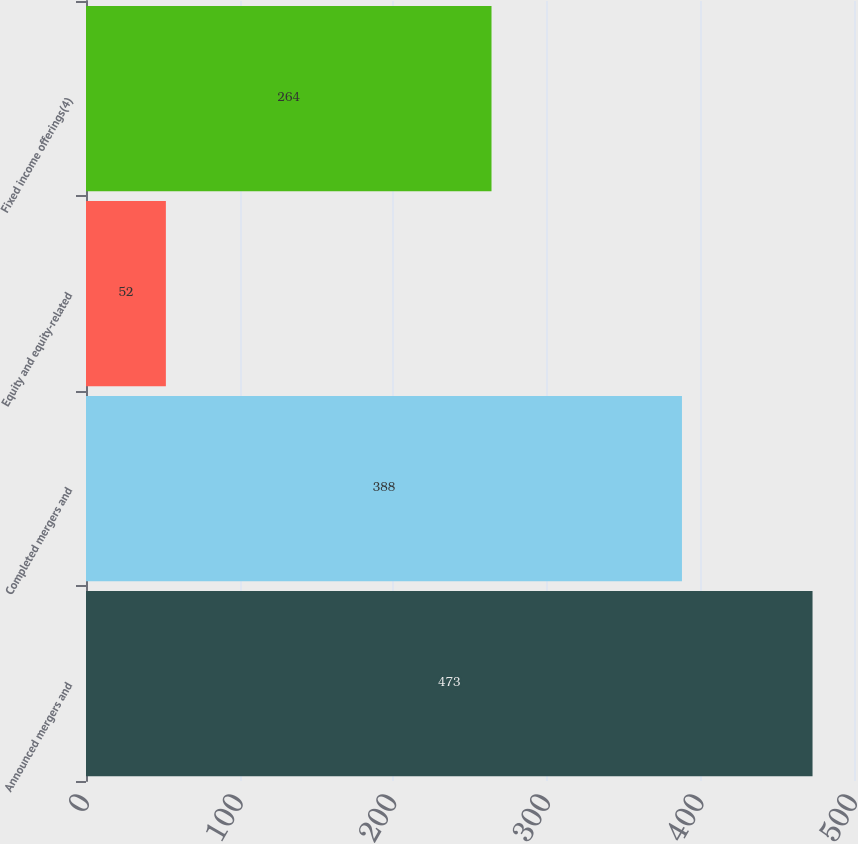Convert chart. <chart><loc_0><loc_0><loc_500><loc_500><bar_chart><fcel>Announced mergers and<fcel>Completed mergers and<fcel>Equity and equity-related<fcel>Fixed income offerings(4)<nl><fcel>473<fcel>388<fcel>52<fcel>264<nl></chart> 